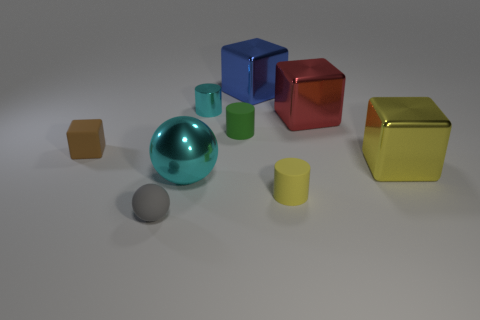Which objects appear to have a metallic finish? In the image, the objects with a metallic finish include the large cyan sphere, the blue cube, the red cube, and the green cube. They exhibit shiny surfaces that reflect light, giving them a metallic look. 